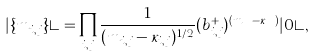Convert formula to latex. <formula><loc_0><loc_0><loc_500><loc_500>| \{ m _ { i , j } \} \rangle = \prod _ { i , j } \frac { 1 } { ( m _ { i , j } - \kappa _ { i , j } ) ^ { 1 / 2 } } ( b _ { i , j } ^ { + } ) ^ { ( m _ { i , j } - \kappa _ { i , j } ) } | 0 \rangle ,</formula> 